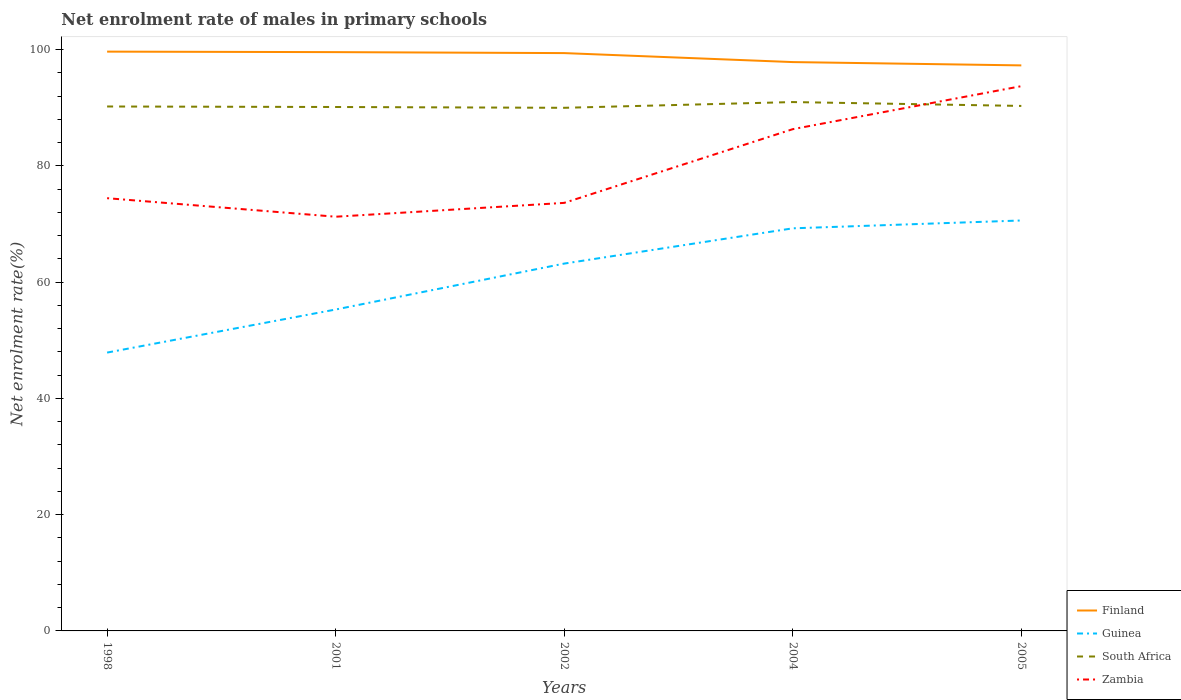How many different coloured lines are there?
Provide a succinct answer. 4. Does the line corresponding to Finland intersect with the line corresponding to Guinea?
Give a very brief answer. No. Across all years, what is the maximum net enrolment rate of males in primary schools in Finland?
Your answer should be compact. 97.31. What is the total net enrolment rate of males in primary schools in South Africa in the graph?
Offer a very short reply. 0.14. What is the difference between the highest and the second highest net enrolment rate of males in primary schools in Finland?
Make the answer very short. 2.37. Is the net enrolment rate of males in primary schools in South Africa strictly greater than the net enrolment rate of males in primary schools in Zambia over the years?
Your answer should be compact. No. How many years are there in the graph?
Make the answer very short. 5. What is the difference between two consecutive major ticks on the Y-axis?
Give a very brief answer. 20. Does the graph contain any zero values?
Provide a short and direct response. No. Does the graph contain grids?
Your answer should be compact. No. Where does the legend appear in the graph?
Ensure brevity in your answer.  Bottom right. How are the legend labels stacked?
Provide a succinct answer. Vertical. What is the title of the graph?
Your answer should be very brief. Net enrolment rate of males in primary schools. Does "Germany" appear as one of the legend labels in the graph?
Provide a short and direct response. No. What is the label or title of the X-axis?
Offer a very short reply. Years. What is the label or title of the Y-axis?
Provide a succinct answer. Net enrolment rate(%). What is the Net enrolment rate(%) of Finland in 1998?
Provide a succinct answer. 99.68. What is the Net enrolment rate(%) in Guinea in 1998?
Make the answer very short. 47.89. What is the Net enrolment rate(%) in South Africa in 1998?
Your answer should be compact. 90.24. What is the Net enrolment rate(%) in Zambia in 1998?
Your answer should be very brief. 74.46. What is the Net enrolment rate(%) of Finland in 2001?
Provide a succinct answer. 99.59. What is the Net enrolment rate(%) in Guinea in 2001?
Your response must be concise. 55.31. What is the Net enrolment rate(%) of South Africa in 2001?
Offer a very short reply. 90.15. What is the Net enrolment rate(%) in Zambia in 2001?
Provide a succinct answer. 71.27. What is the Net enrolment rate(%) of Finland in 2002?
Your answer should be very brief. 99.42. What is the Net enrolment rate(%) of Guinea in 2002?
Your answer should be compact. 63.21. What is the Net enrolment rate(%) in South Africa in 2002?
Your answer should be very brief. 90.01. What is the Net enrolment rate(%) of Zambia in 2002?
Ensure brevity in your answer.  73.65. What is the Net enrolment rate(%) of Finland in 2004?
Your response must be concise. 97.88. What is the Net enrolment rate(%) of Guinea in 2004?
Give a very brief answer. 69.27. What is the Net enrolment rate(%) in South Africa in 2004?
Give a very brief answer. 91. What is the Net enrolment rate(%) in Zambia in 2004?
Your answer should be very brief. 86.33. What is the Net enrolment rate(%) in Finland in 2005?
Your answer should be very brief. 97.31. What is the Net enrolment rate(%) in Guinea in 2005?
Ensure brevity in your answer.  70.62. What is the Net enrolment rate(%) of South Africa in 2005?
Provide a short and direct response. 90.33. What is the Net enrolment rate(%) of Zambia in 2005?
Your answer should be very brief. 93.74. Across all years, what is the maximum Net enrolment rate(%) of Finland?
Provide a succinct answer. 99.68. Across all years, what is the maximum Net enrolment rate(%) in Guinea?
Ensure brevity in your answer.  70.62. Across all years, what is the maximum Net enrolment rate(%) of South Africa?
Keep it short and to the point. 91. Across all years, what is the maximum Net enrolment rate(%) in Zambia?
Your answer should be very brief. 93.74. Across all years, what is the minimum Net enrolment rate(%) in Finland?
Make the answer very short. 97.31. Across all years, what is the minimum Net enrolment rate(%) in Guinea?
Offer a very short reply. 47.89. Across all years, what is the minimum Net enrolment rate(%) in South Africa?
Make the answer very short. 90.01. Across all years, what is the minimum Net enrolment rate(%) in Zambia?
Offer a very short reply. 71.27. What is the total Net enrolment rate(%) in Finland in the graph?
Your response must be concise. 493.88. What is the total Net enrolment rate(%) of Guinea in the graph?
Your answer should be compact. 306.3. What is the total Net enrolment rate(%) of South Africa in the graph?
Your answer should be very brief. 451.73. What is the total Net enrolment rate(%) of Zambia in the graph?
Make the answer very short. 399.45. What is the difference between the Net enrolment rate(%) of Finland in 1998 and that in 2001?
Your response must be concise. 0.09. What is the difference between the Net enrolment rate(%) in Guinea in 1998 and that in 2001?
Your answer should be very brief. -7.41. What is the difference between the Net enrolment rate(%) in South Africa in 1998 and that in 2001?
Give a very brief answer. 0.09. What is the difference between the Net enrolment rate(%) of Zambia in 1998 and that in 2001?
Provide a succinct answer. 3.19. What is the difference between the Net enrolment rate(%) of Finland in 1998 and that in 2002?
Make the answer very short. 0.25. What is the difference between the Net enrolment rate(%) of Guinea in 1998 and that in 2002?
Provide a succinct answer. -15.31. What is the difference between the Net enrolment rate(%) of South Africa in 1998 and that in 2002?
Offer a very short reply. 0.23. What is the difference between the Net enrolment rate(%) in Zambia in 1998 and that in 2002?
Give a very brief answer. 0.81. What is the difference between the Net enrolment rate(%) of Finland in 1998 and that in 2004?
Give a very brief answer. 1.8. What is the difference between the Net enrolment rate(%) in Guinea in 1998 and that in 2004?
Ensure brevity in your answer.  -21.38. What is the difference between the Net enrolment rate(%) in South Africa in 1998 and that in 2004?
Keep it short and to the point. -0.76. What is the difference between the Net enrolment rate(%) of Zambia in 1998 and that in 2004?
Provide a succinct answer. -11.87. What is the difference between the Net enrolment rate(%) in Finland in 1998 and that in 2005?
Provide a succinct answer. 2.37. What is the difference between the Net enrolment rate(%) of Guinea in 1998 and that in 2005?
Provide a succinct answer. -22.73. What is the difference between the Net enrolment rate(%) of South Africa in 1998 and that in 2005?
Ensure brevity in your answer.  -0.1. What is the difference between the Net enrolment rate(%) of Zambia in 1998 and that in 2005?
Provide a short and direct response. -19.27. What is the difference between the Net enrolment rate(%) in Finland in 2001 and that in 2002?
Your answer should be compact. 0.17. What is the difference between the Net enrolment rate(%) in South Africa in 2001 and that in 2002?
Provide a short and direct response. 0.14. What is the difference between the Net enrolment rate(%) in Zambia in 2001 and that in 2002?
Offer a terse response. -2.38. What is the difference between the Net enrolment rate(%) in Finland in 2001 and that in 2004?
Provide a succinct answer. 1.71. What is the difference between the Net enrolment rate(%) of Guinea in 2001 and that in 2004?
Your response must be concise. -13.97. What is the difference between the Net enrolment rate(%) in South Africa in 2001 and that in 2004?
Make the answer very short. -0.85. What is the difference between the Net enrolment rate(%) of Zambia in 2001 and that in 2004?
Your answer should be very brief. -15.06. What is the difference between the Net enrolment rate(%) in Finland in 2001 and that in 2005?
Offer a very short reply. 2.28. What is the difference between the Net enrolment rate(%) of Guinea in 2001 and that in 2005?
Offer a very short reply. -15.32. What is the difference between the Net enrolment rate(%) in South Africa in 2001 and that in 2005?
Keep it short and to the point. -0.18. What is the difference between the Net enrolment rate(%) of Zambia in 2001 and that in 2005?
Offer a terse response. -22.46. What is the difference between the Net enrolment rate(%) of Finland in 2002 and that in 2004?
Your answer should be very brief. 1.55. What is the difference between the Net enrolment rate(%) in Guinea in 2002 and that in 2004?
Give a very brief answer. -6.07. What is the difference between the Net enrolment rate(%) of South Africa in 2002 and that in 2004?
Provide a succinct answer. -0.99. What is the difference between the Net enrolment rate(%) of Zambia in 2002 and that in 2004?
Your response must be concise. -12.68. What is the difference between the Net enrolment rate(%) of Finland in 2002 and that in 2005?
Ensure brevity in your answer.  2.12. What is the difference between the Net enrolment rate(%) in Guinea in 2002 and that in 2005?
Keep it short and to the point. -7.42. What is the difference between the Net enrolment rate(%) in South Africa in 2002 and that in 2005?
Provide a short and direct response. -0.32. What is the difference between the Net enrolment rate(%) of Zambia in 2002 and that in 2005?
Offer a very short reply. -20.08. What is the difference between the Net enrolment rate(%) in Finland in 2004 and that in 2005?
Keep it short and to the point. 0.57. What is the difference between the Net enrolment rate(%) in Guinea in 2004 and that in 2005?
Give a very brief answer. -1.35. What is the difference between the Net enrolment rate(%) in South Africa in 2004 and that in 2005?
Offer a very short reply. 0.67. What is the difference between the Net enrolment rate(%) of Zambia in 2004 and that in 2005?
Ensure brevity in your answer.  -7.4. What is the difference between the Net enrolment rate(%) of Finland in 1998 and the Net enrolment rate(%) of Guinea in 2001?
Offer a very short reply. 44.37. What is the difference between the Net enrolment rate(%) of Finland in 1998 and the Net enrolment rate(%) of South Africa in 2001?
Ensure brevity in your answer.  9.53. What is the difference between the Net enrolment rate(%) of Finland in 1998 and the Net enrolment rate(%) of Zambia in 2001?
Give a very brief answer. 28.41. What is the difference between the Net enrolment rate(%) of Guinea in 1998 and the Net enrolment rate(%) of South Africa in 2001?
Ensure brevity in your answer.  -42.26. What is the difference between the Net enrolment rate(%) in Guinea in 1998 and the Net enrolment rate(%) in Zambia in 2001?
Make the answer very short. -23.38. What is the difference between the Net enrolment rate(%) in South Africa in 1998 and the Net enrolment rate(%) in Zambia in 2001?
Your answer should be very brief. 18.97. What is the difference between the Net enrolment rate(%) in Finland in 1998 and the Net enrolment rate(%) in Guinea in 2002?
Keep it short and to the point. 36.47. What is the difference between the Net enrolment rate(%) of Finland in 1998 and the Net enrolment rate(%) of South Africa in 2002?
Keep it short and to the point. 9.67. What is the difference between the Net enrolment rate(%) in Finland in 1998 and the Net enrolment rate(%) in Zambia in 2002?
Your answer should be compact. 26.03. What is the difference between the Net enrolment rate(%) of Guinea in 1998 and the Net enrolment rate(%) of South Africa in 2002?
Provide a short and direct response. -42.12. What is the difference between the Net enrolment rate(%) of Guinea in 1998 and the Net enrolment rate(%) of Zambia in 2002?
Your answer should be very brief. -25.76. What is the difference between the Net enrolment rate(%) of South Africa in 1998 and the Net enrolment rate(%) of Zambia in 2002?
Keep it short and to the point. 16.59. What is the difference between the Net enrolment rate(%) in Finland in 1998 and the Net enrolment rate(%) in Guinea in 2004?
Your response must be concise. 30.4. What is the difference between the Net enrolment rate(%) in Finland in 1998 and the Net enrolment rate(%) in South Africa in 2004?
Your response must be concise. 8.68. What is the difference between the Net enrolment rate(%) in Finland in 1998 and the Net enrolment rate(%) in Zambia in 2004?
Provide a succinct answer. 13.34. What is the difference between the Net enrolment rate(%) of Guinea in 1998 and the Net enrolment rate(%) of South Africa in 2004?
Your answer should be very brief. -43.11. What is the difference between the Net enrolment rate(%) of Guinea in 1998 and the Net enrolment rate(%) of Zambia in 2004?
Offer a terse response. -38.44. What is the difference between the Net enrolment rate(%) of South Africa in 1998 and the Net enrolment rate(%) of Zambia in 2004?
Your answer should be very brief. 3.9. What is the difference between the Net enrolment rate(%) in Finland in 1998 and the Net enrolment rate(%) in Guinea in 2005?
Provide a succinct answer. 29.05. What is the difference between the Net enrolment rate(%) in Finland in 1998 and the Net enrolment rate(%) in South Africa in 2005?
Offer a very short reply. 9.35. What is the difference between the Net enrolment rate(%) in Finland in 1998 and the Net enrolment rate(%) in Zambia in 2005?
Make the answer very short. 5.94. What is the difference between the Net enrolment rate(%) in Guinea in 1998 and the Net enrolment rate(%) in South Africa in 2005?
Keep it short and to the point. -42.44. What is the difference between the Net enrolment rate(%) in Guinea in 1998 and the Net enrolment rate(%) in Zambia in 2005?
Offer a very short reply. -45.84. What is the difference between the Net enrolment rate(%) in South Africa in 1998 and the Net enrolment rate(%) in Zambia in 2005?
Make the answer very short. -3.5. What is the difference between the Net enrolment rate(%) of Finland in 2001 and the Net enrolment rate(%) of Guinea in 2002?
Provide a short and direct response. 36.39. What is the difference between the Net enrolment rate(%) of Finland in 2001 and the Net enrolment rate(%) of South Africa in 2002?
Your answer should be very brief. 9.58. What is the difference between the Net enrolment rate(%) in Finland in 2001 and the Net enrolment rate(%) in Zambia in 2002?
Keep it short and to the point. 25.94. What is the difference between the Net enrolment rate(%) in Guinea in 2001 and the Net enrolment rate(%) in South Africa in 2002?
Your answer should be very brief. -34.71. What is the difference between the Net enrolment rate(%) in Guinea in 2001 and the Net enrolment rate(%) in Zambia in 2002?
Your answer should be very brief. -18.35. What is the difference between the Net enrolment rate(%) of South Africa in 2001 and the Net enrolment rate(%) of Zambia in 2002?
Provide a succinct answer. 16.5. What is the difference between the Net enrolment rate(%) in Finland in 2001 and the Net enrolment rate(%) in Guinea in 2004?
Keep it short and to the point. 30.32. What is the difference between the Net enrolment rate(%) of Finland in 2001 and the Net enrolment rate(%) of South Africa in 2004?
Your answer should be compact. 8.59. What is the difference between the Net enrolment rate(%) of Finland in 2001 and the Net enrolment rate(%) of Zambia in 2004?
Your answer should be very brief. 13.26. What is the difference between the Net enrolment rate(%) of Guinea in 2001 and the Net enrolment rate(%) of South Africa in 2004?
Provide a short and direct response. -35.69. What is the difference between the Net enrolment rate(%) of Guinea in 2001 and the Net enrolment rate(%) of Zambia in 2004?
Make the answer very short. -31.03. What is the difference between the Net enrolment rate(%) of South Africa in 2001 and the Net enrolment rate(%) of Zambia in 2004?
Provide a succinct answer. 3.81. What is the difference between the Net enrolment rate(%) of Finland in 2001 and the Net enrolment rate(%) of Guinea in 2005?
Your response must be concise. 28.97. What is the difference between the Net enrolment rate(%) in Finland in 2001 and the Net enrolment rate(%) in South Africa in 2005?
Provide a short and direct response. 9.26. What is the difference between the Net enrolment rate(%) in Finland in 2001 and the Net enrolment rate(%) in Zambia in 2005?
Your answer should be compact. 5.86. What is the difference between the Net enrolment rate(%) of Guinea in 2001 and the Net enrolment rate(%) of South Africa in 2005?
Make the answer very short. -35.03. What is the difference between the Net enrolment rate(%) in Guinea in 2001 and the Net enrolment rate(%) in Zambia in 2005?
Your answer should be compact. -38.43. What is the difference between the Net enrolment rate(%) in South Africa in 2001 and the Net enrolment rate(%) in Zambia in 2005?
Keep it short and to the point. -3.59. What is the difference between the Net enrolment rate(%) in Finland in 2002 and the Net enrolment rate(%) in Guinea in 2004?
Offer a very short reply. 30.15. What is the difference between the Net enrolment rate(%) in Finland in 2002 and the Net enrolment rate(%) in South Africa in 2004?
Provide a succinct answer. 8.43. What is the difference between the Net enrolment rate(%) in Finland in 2002 and the Net enrolment rate(%) in Zambia in 2004?
Your response must be concise. 13.09. What is the difference between the Net enrolment rate(%) of Guinea in 2002 and the Net enrolment rate(%) of South Africa in 2004?
Your answer should be compact. -27.79. What is the difference between the Net enrolment rate(%) of Guinea in 2002 and the Net enrolment rate(%) of Zambia in 2004?
Make the answer very short. -23.13. What is the difference between the Net enrolment rate(%) of South Africa in 2002 and the Net enrolment rate(%) of Zambia in 2004?
Your response must be concise. 3.68. What is the difference between the Net enrolment rate(%) of Finland in 2002 and the Net enrolment rate(%) of Guinea in 2005?
Provide a succinct answer. 28.8. What is the difference between the Net enrolment rate(%) in Finland in 2002 and the Net enrolment rate(%) in South Africa in 2005?
Your response must be concise. 9.09. What is the difference between the Net enrolment rate(%) in Finland in 2002 and the Net enrolment rate(%) in Zambia in 2005?
Your response must be concise. 5.69. What is the difference between the Net enrolment rate(%) of Guinea in 2002 and the Net enrolment rate(%) of South Africa in 2005?
Your response must be concise. -27.13. What is the difference between the Net enrolment rate(%) in Guinea in 2002 and the Net enrolment rate(%) in Zambia in 2005?
Ensure brevity in your answer.  -30.53. What is the difference between the Net enrolment rate(%) of South Africa in 2002 and the Net enrolment rate(%) of Zambia in 2005?
Keep it short and to the point. -3.72. What is the difference between the Net enrolment rate(%) of Finland in 2004 and the Net enrolment rate(%) of Guinea in 2005?
Offer a terse response. 27.26. What is the difference between the Net enrolment rate(%) of Finland in 2004 and the Net enrolment rate(%) of South Africa in 2005?
Your answer should be very brief. 7.55. What is the difference between the Net enrolment rate(%) in Finland in 2004 and the Net enrolment rate(%) in Zambia in 2005?
Your response must be concise. 4.14. What is the difference between the Net enrolment rate(%) in Guinea in 2004 and the Net enrolment rate(%) in South Africa in 2005?
Give a very brief answer. -21.06. What is the difference between the Net enrolment rate(%) in Guinea in 2004 and the Net enrolment rate(%) in Zambia in 2005?
Keep it short and to the point. -24.46. What is the difference between the Net enrolment rate(%) of South Africa in 2004 and the Net enrolment rate(%) of Zambia in 2005?
Ensure brevity in your answer.  -2.74. What is the average Net enrolment rate(%) in Finland per year?
Keep it short and to the point. 98.78. What is the average Net enrolment rate(%) of Guinea per year?
Make the answer very short. 61.26. What is the average Net enrolment rate(%) in South Africa per year?
Give a very brief answer. 90.35. What is the average Net enrolment rate(%) in Zambia per year?
Your response must be concise. 79.89. In the year 1998, what is the difference between the Net enrolment rate(%) of Finland and Net enrolment rate(%) of Guinea?
Offer a very short reply. 51.78. In the year 1998, what is the difference between the Net enrolment rate(%) in Finland and Net enrolment rate(%) in South Africa?
Provide a short and direct response. 9.44. In the year 1998, what is the difference between the Net enrolment rate(%) in Finland and Net enrolment rate(%) in Zambia?
Your answer should be compact. 25.22. In the year 1998, what is the difference between the Net enrolment rate(%) in Guinea and Net enrolment rate(%) in South Africa?
Ensure brevity in your answer.  -42.34. In the year 1998, what is the difference between the Net enrolment rate(%) of Guinea and Net enrolment rate(%) of Zambia?
Provide a short and direct response. -26.57. In the year 1998, what is the difference between the Net enrolment rate(%) of South Africa and Net enrolment rate(%) of Zambia?
Offer a very short reply. 15.78. In the year 2001, what is the difference between the Net enrolment rate(%) in Finland and Net enrolment rate(%) in Guinea?
Provide a short and direct response. 44.29. In the year 2001, what is the difference between the Net enrolment rate(%) of Finland and Net enrolment rate(%) of South Africa?
Offer a very short reply. 9.44. In the year 2001, what is the difference between the Net enrolment rate(%) in Finland and Net enrolment rate(%) in Zambia?
Your answer should be very brief. 28.32. In the year 2001, what is the difference between the Net enrolment rate(%) in Guinea and Net enrolment rate(%) in South Africa?
Your answer should be compact. -34.84. In the year 2001, what is the difference between the Net enrolment rate(%) in Guinea and Net enrolment rate(%) in Zambia?
Give a very brief answer. -15.96. In the year 2001, what is the difference between the Net enrolment rate(%) in South Africa and Net enrolment rate(%) in Zambia?
Make the answer very short. 18.88. In the year 2002, what is the difference between the Net enrolment rate(%) of Finland and Net enrolment rate(%) of Guinea?
Provide a short and direct response. 36.22. In the year 2002, what is the difference between the Net enrolment rate(%) in Finland and Net enrolment rate(%) in South Africa?
Make the answer very short. 9.41. In the year 2002, what is the difference between the Net enrolment rate(%) in Finland and Net enrolment rate(%) in Zambia?
Provide a succinct answer. 25.77. In the year 2002, what is the difference between the Net enrolment rate(%) of Guinea and Net enrolment rate(%) of South Africa?
Give a very brief answer. -26.81. In the year 2002, what is the difference between the Net enrolment rate(%) of Guinea and Net enrolment rate(%) of Zambia?
Keep it short and to the point. -10.45. In the year 2002, what is the difference between the Net enrolment rate(%) in South Africa and Net enrolment rate(%) in Zambia?
Offer a very short reply. 16.36. In the year 2004, what is the difference between the Net enrolment rate(%) of Finland and Net enrolment rate(%) of Guinea?
Give a very brief answer. 28.61. In the year 2004, what is the difference between the Net enrolment rate(%) of Finland and Net enrolment rate(%) of South Africa?
Provide a short and direct response. 6.88. In the year 2004, what is the difference between the Net enrolment rate(%) in Finland and Net enrolment rate(%) in Zambia?
Offer a very short reply. 11.54. In the year 2004, what is the difference between the Net enrolment rate(%) of Guinea and Net enrolment rate(%) of South Africa?
Your response must be concise. -21.72. In the year 2004, what is the difference between the Net enrolment rate(%) in Guinea and Net enrolment rate(%) in Zambia?
Provide a succinct answer. -17.06. In the year 2004, what is the difference between the Net enrolment rate(%) in South Africa and Net enrolment rate(%) in Zambia?
Your answer should be very brief. 4.66. In the year 2005, what is the difference between the Net enrolment rate(%) of Finland and Net enrolment rate(%) of Guinea?
Offer a terse response. 26.69. In the year 2005, what is the difference between the Net enrolment rate(%) of Finland and Net enrolment rate(%) of South Africa?
Make the answer very short. 6.98. In the year 2005, what is the difference between the Net enrolment rate(%) in Finland and Net enrolment rate(%) in Zambia?
Make the answer very short. 3.57. In the year 2005, what is the difference between the Net enrolment rate(%) in Guinea and Net enrolment rate(%) in South Africa?
Offer a terse response. -19.71. In the year 2005, what is the difference between the Net enrolment rate(%) in Guinea and Net enrolment rate(%) in Zambia?
Your response must be concise. -23.11. In the year 2005, what is the difference between the Net enrolment rate(%) in South Africa and Net enrolment rate(%) in Zambia?
Give a very brief answer. -3.4. What is the ratio of the Net enrolment rate(%) of Guinea in 1998 to that in 2001?
Offer a very short reply. 0.87. What is the ratio of the Net enrolment rate(%) of Zambia in 1998 to that in 2001?
Provide a short and direct response. 1.04. What is the ratio of the Net enrolment rate(%) of Finland in 1998 to that in 2002?
Give a very brief answer. 1. What is the ratio of the Net enrolment rate(%) in Guinea in 1998 to that in 2002?
Keep it short and to the point. 0.76. What is the ratio of the Net enrolment rate(%) of Zambia in 1998 to that in 2002?
Ensure brevity in your answer.  1.01. What is the ratio of the Net enrolment rate(%) in Finland in 1998 to that in 2004?
Give a very brief answer. 1.02. What is the ratio of the Net enrolment rate(%) in Guinea in 1998 to that in 2004?
Offer a very short reply. 0.69. What is the ratio of the Net enrolment rate(%) of Zambia in 1998 to that in 2004?
Your answer should be very brief. 0.86. What is the ratio of the Net enrolment rate(%) of Finland in 1998 to that in 2005?
Ensure brevity in your answer.  1.02. What is the ratio of the Net enrolment rate(%) of Guinea in 1998 to that in 2005?
Your answer should be very brief. 0.68. What is the ratio of the Net enrolment rate(%) in South Africa in 1998 to that in 2005?
Make the answer very short. 1. What is the ratio of the Net enrolment rate(%) of Zambia in 1998 to that in 2005?
Give a very brief answer. 0.79. What is the ratio of the Net enrolment rate(%) of Finland in 2001 to that in 2002?
Provide a succinct answer. 1. What is the ratio of the Net enrolment rate(%) in Guinea in 2001 to that in 2002?
Give a very brief answer. 0.88. What is the ratio of the Net enrolment rate(%) in Finland in 2001 to that in 2004?
Provide a short and direct response. 1.02. What is the ratio of the Net enrolment rate(%) of Guinea in 2001 to that in 2004?
Make the answer very short. 0.8. What is the ratio of the Net enrolment rate(%) of Zambia in 2001 to that in 2004?
Ensure brevity in your answer.  0.83. What is the ratio of the Net enrolment rate(%) of Finland in 2001 to that in 2005?
Your response must be concise. 1.02. What is the ratio of the Net enrolment rate(%) in Guinea in 2001 to that in 2005?
Your answer should be compact. 0.78. What is the ratio of the Net enrolment rate(%) of South Africa in 2001 to that in 2005?
Your response must be concise. 1. What is the ratio of the Net enrolment rate(%) in Zambia in 2001 to that in 2005?
Make the answer very short. 0.76. What is the ratio of the Net enrolment rate(%) in Finland in 2002 to that in 2004?
Ensure brevity in your answer.  1.02. What is the ratio of the Net enrolment rate(%) of Guinea in 2002 to that in 2004?
Provide a succinct answer. 0.91. What is the ratio of the Net enrolment rate(%) of Zambia in 2002 to that in 2004?
Keep it short and to the point. 0.85. What is the ratio of the Net enrolment rate(%) of Finland in 2002 to that in 2005?
Your answer should be compact. 1.02. What is the ratio of the Net enrolment rate(%) of Guinea in 2002 to that in 2005?
Offer a terse response. 0.9. What is the ratio of the Net enrolment rate(%) of South Africa in 2002 to that in 2005?
Provide a succinct answer. 1. What is the ratio of the Net enrolment rate(%) in Zambia in 2002 to that in 2005?
Your answer should be compact. 0.79. What is the ratio of the Net enrolment rate(%) of Finland in 2004 to that in 2005?
Offer a terse response. 1.01. What is the ratio of the Net enrolment rate(%) of Guinea in 2004 to that in 2005?
Provide a short and direct response. 0.98. What is the ratio of the Net enrolment rate(%) of South Africa in 2004 to that in 2005?
Ensure brevity in your answer.  1.01. What is the ratio of the Net enrolment rate(%) in Zambia in 2004 to that in 2005?
Your response must be concise. 0.92. What is the difference between the highest and the second highest Net enrolment rate(%) in Finland?
Your answer should be very brief. 0.09. What is the difference between the highest and the second highest Net enrolment rate(%) in Guinea?
Keep it short and to the point. 1.35. What is the difference between the highest and the second highest Net enrolment rate(%) of South Africa?
Keep it short and to the point. 0.67. What is the difference between the highest and the second highest Net enrolment rate(%) of Zambia?
Make the answer very short. 7.4. What is the difference between the highest and the lowest Net enrolment rate(%) in Finland?
Give a very brief answer. 2.37. What is the difference between the highest and the lowest Net enrolment rate(%) in Guinea?
Give a very brief answer. 22.73. What is the difference between the highest and the lowest Net enrolment rate(%) in South Africa?
Your response must be concise. 0.99. What is the difference between the highest and the lowest Net enrolment rate(%) in Zambia?
Make the answer very short. 22.46. 